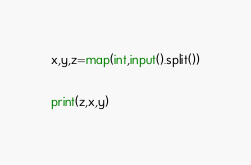<code> <loc_0><loc_0><loc_500><loc_500><_Python_>x,y,z=map(int,input().split())

print(z,x,y)</code> 